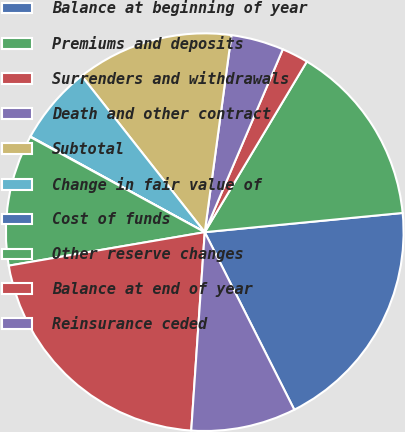Convert chart. <chart><loc_0><loc_0><loc_500><loc_500><pie_chart><fcel>Balance at beginning of year<fcel>Premiums and deposits<fcel>Surrenders and withdrawals<fcel>Death and other contract<fcel>Subtotal<fcel>Change in fair value of<fcel>Cost of funds<fcel>Other reserve changes<fcel>Balance at end of year<fcel>Reinsurance ceded<nl><fcel>19.11%<fcel>14.88%<fcel>2.16%<fcel>4.28%<fcel>12.76%<fcel>6.4%<fcel>0.04%<fcel>10.64%<fcel>21.23%<fcel>8.52%<nl></chart> 